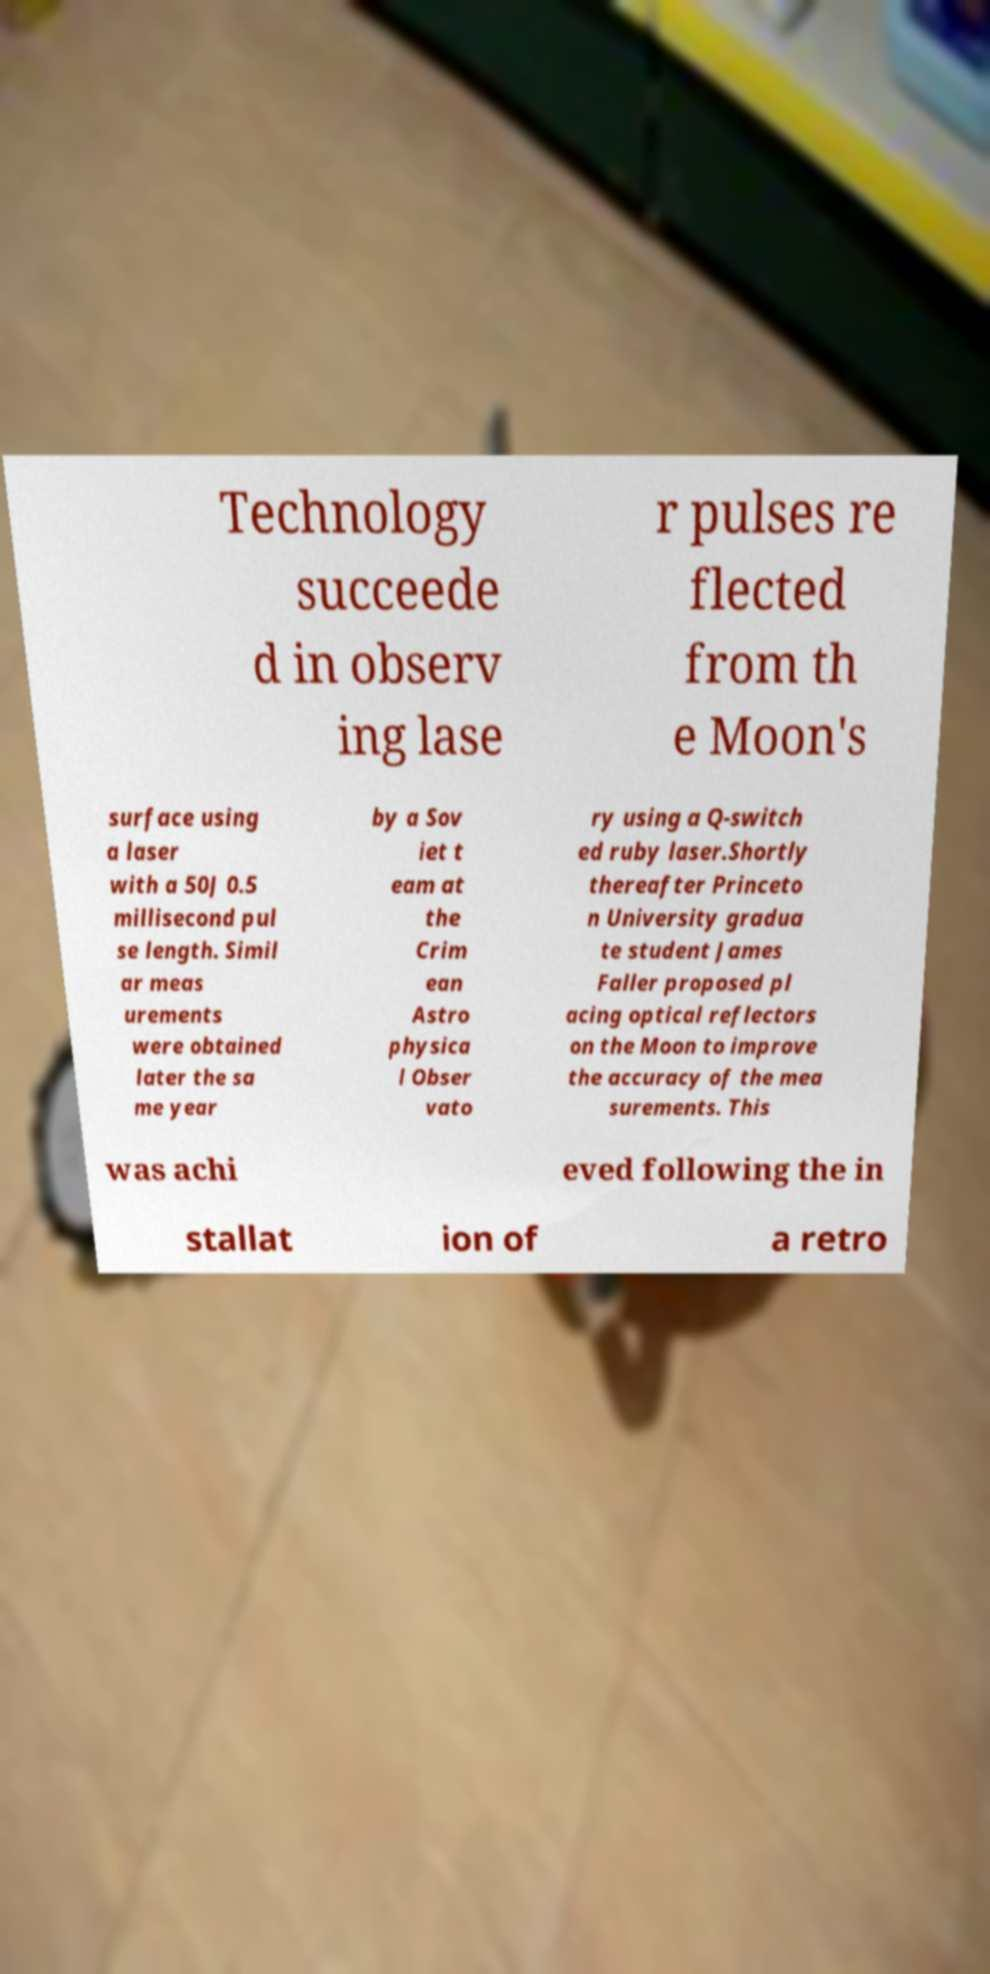There's text embedded in this image that I need extracted. Can you transcribe it verbatim? Technology succeede d in observ ing lase r pulses re flected from th e Moon's surface using a laser with a 50J 0.5 millisecond pul se length. Simil ar meas urements were obtained later the sa me year by a Sov iet t eam at the Crim ean Astro physica l Obser vato ry using a Q-switch ed ruby laser.Shortly thereafter Princeto n University gradua te student James Faller proposed pl acing optical reflectors on the Moon to improve the accuracy of the mea surements. This was achi eved following the in stallat ion of a retro 